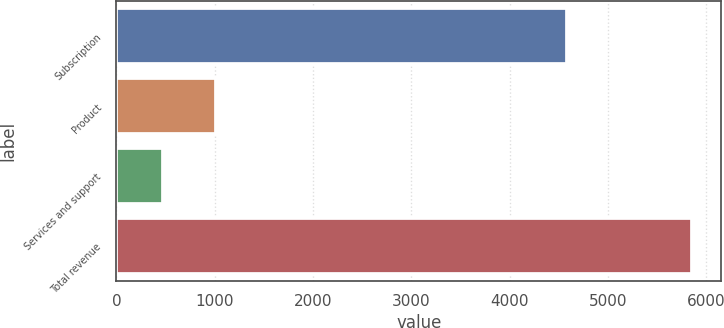<chart> <loc_0><loc_0><loc_500><loc_500><bar_chart><fcel>Subscription<fcel>Product<fcel>Services and support<fcel>Total revenue<nl><fcel>4584.8<fcel>1007.63<fcel>469.1<fcel>5854.4<nl></chart> 